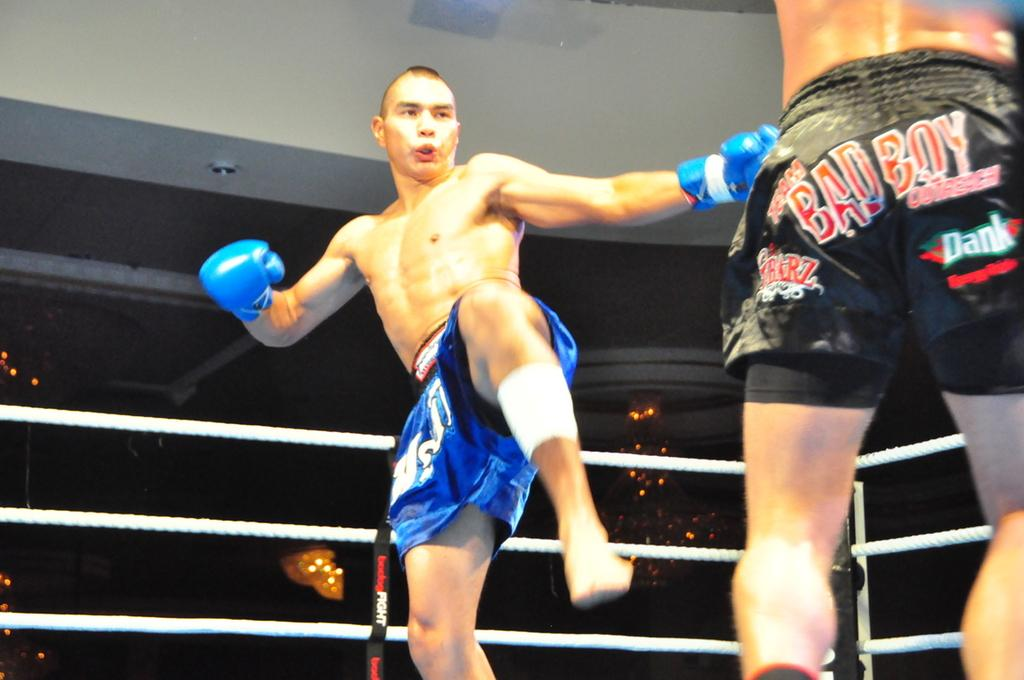<image>
Offer a succinct explanation of the picture presented. two fighters in a ring with one of them wearing a Bad Boy shorts and the other has blue gloves with blue shorts. 